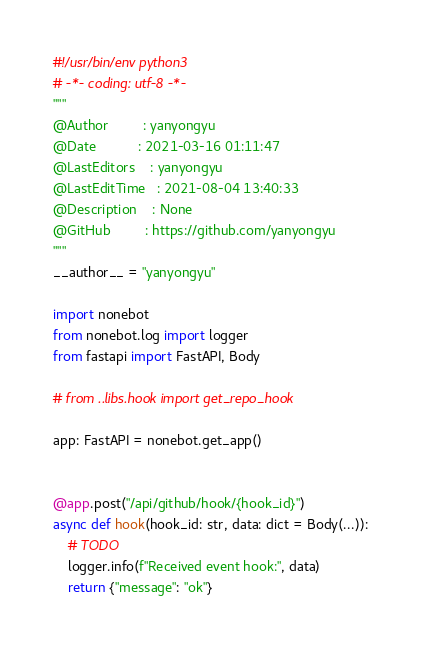<code> <loc_0><loc_0><loc_500><loc_500><_Python_>#!/usr/bin/env python3
# -*- coding: utf-8 -*-
"""
@Author         : yanyongyu
@Date           : 2021-03-16 01:11:47
@LastEditors    : yanyongyu
@LastEditTime   : 2021-08-04 13:40:33
@Description    : None
@GitHub         : https://github.com/yanyongyu
"""
__author__ = "yanyongyu"

import nonebot
from nonebot.log import logger
from fastapi import FastAPI, Body

# from ..libs.hook import get_repo_hook

app: FastAPI = nonebot.get_app()


@app.post("/api/github/hook/{hook_id}")
async def hook(hook_id: str, data: dict = Body(...)):
    # TODO
    logger.info(f"Received event hook:", data)
    return {"message": "ok"}
</code> 